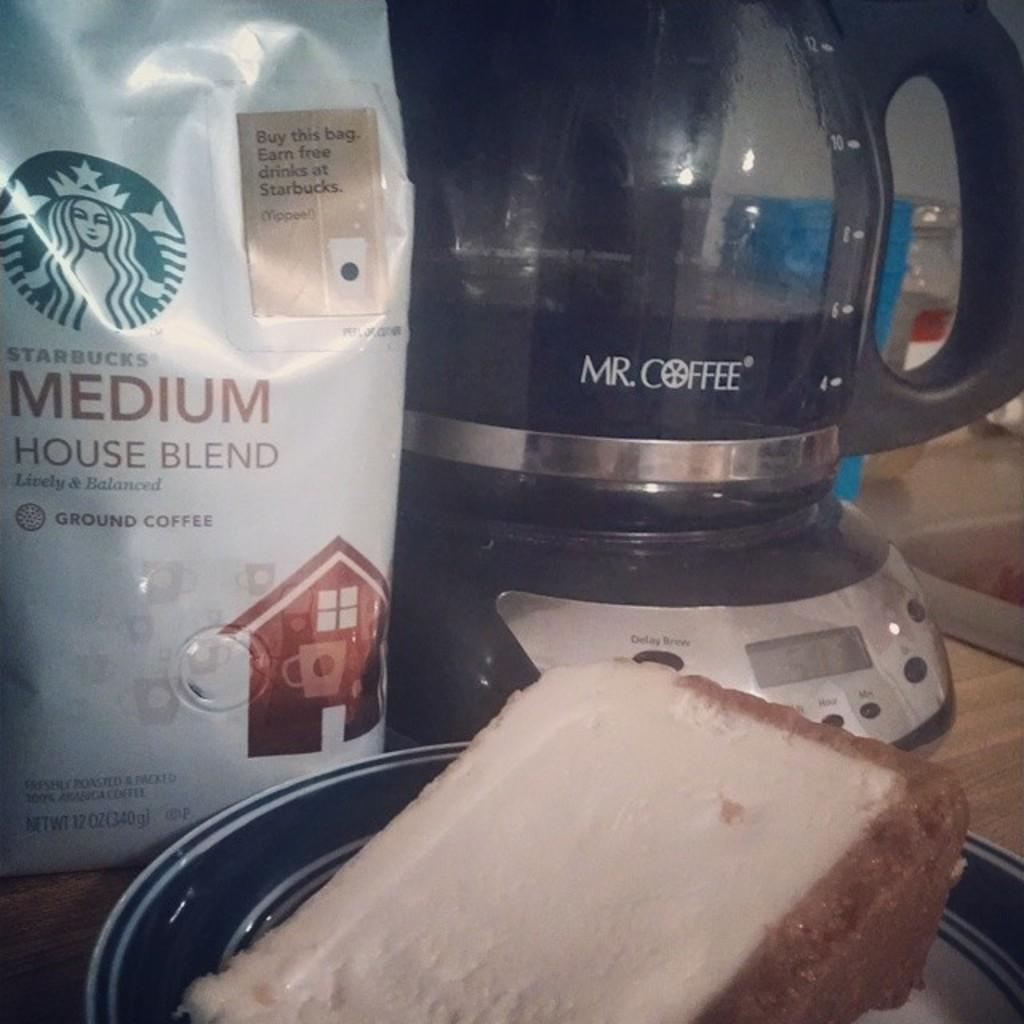<image>
Render a clear and concise summary of the photo. a me coffee maker is sitting with coffee and cake 